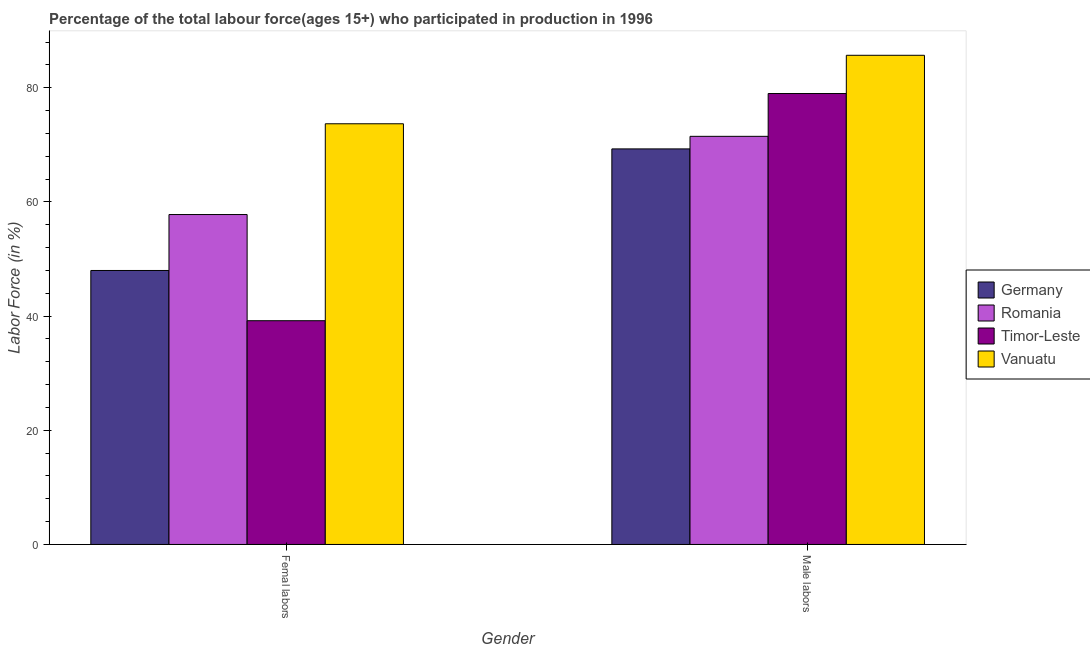How many different coloured bars are there?
Provide a short and direct response. 4. Are the number of bars on each tick of the X-axis equal?
Give a very brief answer. Yes. How many bars are there on the 2nd tick from the left?
Give a very brief answer. 4. What is the label of the 1st group of bars from the left?
Your answer should be very brief. Femal labors. What is the percentage of male labour force in Germany?
Offer a very short reply. 69.3. Across all countries, what is the maximum percentage of female labor force?
Provide a succinct answer. 73.7. Across all countries, what is the minimum percentage of male labour force?
Provide a succinct answer. 69.3. In which country was the percentage of male labour force maximum?
Provide a short and direct response. Vanuatu. In which country was the percentage of male labour force minimum?
Provide a succinct answer. Germany. What is the total percentage of male labour force in the graph?
Your answer should be very brief. 305.5. What is the difference between the percentage of female labor force in Timor-Leste and that in Romania?
Offer a terse response. -18.6. What is the difference between the percentage of male labour force in Germany and the percentage of female labor force in Timor-Leste?
Your answer should be compact. 30.1. What is the average percentage of female labor force per country?
Give a very brief answer. 54.67. What is the difference between the percentage of male labour force and percentage of female labor force in Germany?
Offer a terse response. 21.3. What is the ratio of the percentage of female labor force in Timor-Leste to that in Vanuatu?
Ensure brevity in your answer.  0.53. Is the percentage of male labour force in Vanuatu less than that in Timor-Leste?
Offer a very short reply. No. What does the 3rd bar from the left in Male labors represents?
Offer a terse response. Timor-Leste. What does the 4th bar from the right in Male labors represents?
Keep it short and to the point. Germany. Are the values on the major ticks of Y-axis written in scientific E-notation?
Your response must be concise. No. Does the graph contain grids?
Provide a succinct answer. No. How many legend labels are there?
Your answer should be compact. 4. How are the legend labels stacked?
Your answer should be compact. Vertical. What is the title of the graph?
Give a very brief answer. Percentage of the total labour force(ages 15+) who participated in production in 1996. Does "Trinidad and Tobago" appear as one of the legend labels in the graph?
Your response must be concise. No. What is the Labor Force (in %) in Romania in Femal labors?
Your answer should be compact. 57.8. What is the Labor Force (in %) of Timor-Leste in Femal labors?
Make the answer very short. 39.2. What is the Labor Force (in %) of Vanuatu in Femal labors?
Give a very brief answer. 73.7. What is the Labor Force (in %) in Germany in Male labors?
Your answer should be very brief. 69.3. What is the Labor Force (in %) in Romania in Male labors?
Ensure brevity in your answer.  71.5. What is the Labor Force (in %) of Timor-Leste in Male labors?
Offer a very short reply. 79. What is the Labor Force (in %) in Vanuatu in Male labors?
Give a very brief answer. 85.7. Across all Gender, what is the maximum Labor Force (in %) of Germany?
Keep it short and to the point. 69.3. Across all Gender, what is the maximum Labor Force (in %) of Romania?
Offer a terse response. 71.5. Across all Gender, what is the maximum Labor Force (in %) of Timor-Leste?
Ensure brevity in your answer.  79. Across all Gender, what is the maximum Labor Force (in %) in Vanuatu?
Your answer should be compact. 85.7. Across all Gender, what is the minimum Labor Force (in %) of Germany?
Make the answer very short. 48. Across all Gender, what is the minimum Labor Force (in %) in Romania?
Make the answer very short. 57.8. Across all Gender, what is the minimum Labor Force (in %) in Timor-Leste?
Your answer should be very brief. 39.2. Across all Gender, what is the minimum Labor Force (in %) in Vanuatu?
Ensure brevity in your answer.  73.7. What is the total Labor Force (in %) in Germany in the graph?
Your answer should be very brief. 117.3. What is the total Labor Force (in %) of Romania in the graph?
Make the answer very short. 129.3. What is the total Labor Force (in %) in Timor-Leste in the graph?
Provide a short and direct response. 118.2. What is the total Labor Force (in %) in Vanuatu in the graph?
Ensure brevity in your answer.  159.4. What is the difference between the Labor Force (in %) of Germany in Femal labors and that in Male labors?
Ensure brevity in your answer.  -21.3. What is the difference between the Labor Force (in %) in Romania in Femal labors and that in Male labors?
Keep it short and to the point. -13.7. What is the difference between the Labor Force (in %) in Timor-Leste in Femal labors and that in Male labors?
Ensure brevity in your answer.  -39.8. What is the difference between the Labor Force (in %) in Vanuatu in Femal labors and that in Male labors?
Your answer should be very brief. -12. What is the difference between the Labor Force (in %) of Germany in Femal labors and the Labor Force (in %) of Romania in Male labors?
Keep it short and to the point. -23.5. What is the difference between the Labor Force (in %) of Germany in Femal labors and the Labor Force (in %) of Timor-Leste in Male labors?
Provide a succinct answer. -31. What is the difference between the Labor Force (in %) of Germany in Femal labors and the Labor Force (in %) of Vanuatu in Male labors?
Give a very brief answer. -37.7. What is the difference between the Labor Force (in %) in Romania in Femal labors and the Labor Force (in %) in Timor-Leste in Male labors?
Ensure brevity in your answer.  -21.2. What is the difference between the Labor Force (in %) in Romania in Femal labors and the Labor Force (in %) in Vanuatu in Male labors?
Make the answer very short. -27.9. What is the difference between the Labor Force (in %) of Timor-Leste in Femal labors and the Labor Force (in %) of Vanuatu in Male labors?
Your answer should be very brief. -46.5. What is the average Labor Force (in %) in Germany per Gender?
Your response must be concise. 58.65. What is the average Labor Force (in %) of Romania per Gender?
Keep it short and to the point. 64.65. What is the average Labor Force (in %) of Timor-Leste per Gender?
Your answer should be compact. 59.1. What is the average Labor Force (in %) in Vanuatu per Gender?
Ensure brevity in your answer.  79.7. What is the difference between the Labor Force (in %) of Germany and Labor Force (in %) of Romania in Femal labors?
Your response must be concise. -9.8. What is the difference between the Labor Force (in %) in Germany and Labor Force (in %) in Timor-Leste in Femal labors?
Ensure brevity in your answer.  8.8. What is the difference between the Labor Force (in %) in Germany and Labor Force (in %) in Vanuatu in Femal labors?
Offer a very short reply. -25.7. What is the difference between the Labor Force (in %) of Romania and Labor Force (in %) of Timor-Leste in Femal labors?
Provide a short and direct response. 18.6. What is the difference between the Labor Force (in %) in Romania and Labor Force (in %) in Vanuatu in Femal labors?
Make the answer very short. -15.9. What is the difference between the Labor Force (in %) of Timor-Leste and Labor Force (in %) of Vanuatu in Femal labors?
Your answer should be very brief. -34.5. What is the difference between the Labor Force (in %) of Germany and Labor Force (in %) of Romania in Male labors?
Your answer should be compact. -2.2. What is the difference between the Labor Force (in %) in Germany and Labor Force (in %) in Timor-Leste in Male labors?
Provide a short and direct response. -9.7. What is the difference between the Labor Force (in %) of Germany and Labor Force (in %) of Vanuatu in Male labors?
Keep it short and to the point. -16.4. What is the difference between the Labor Force (in %) in Romania and Labor Force (in %) in Timor-Leste in Male labors?
Give a very brief answer. -7.5. What is the difference between the Labor Force (in %) of Timor-Leste and Labor Force (in %) of Vanuatu in Male labors?
Make the answer very short. -6.7. What is the ratio of the Labor Force (in %) of Germany in Femal labors to that in Male labors?
Offer a very short reply. 0.69. What is the ratio of the Labor Force (in %) in Romania in Femal labors to that in Male labors?
Provide a succinct answer. 0.81. What is the ratio of the Labor Force (in %) of Timor-Leste in Femal labors to that in Male labors?
Give a very brief answer. 0.5. What is the ratio of the Labor Force (in %) of Vanuatu in Femal labors to that in Male labors?
Provide a succinct answer. 0.86. What is the difference between the highest and the second highest Labor Force (in %) in Germany?
Offer a very short reply. 21.3. What is the difference between the highest and the second highest Labor Force (in %) in Romania?
Your answer should be compact. 13.7. What is the difference between the highest and the second highest Labor Force (in %) in Timor-Leste?
Keep it short and to the point. 39.8. What is the difference between the highest and the second highest Labor Force (in %) of Vanuatu?
Your answer should be compact. 12. What is the difference between the highest and the lowest Labor Force (in %) of Germany?
Your answer should be compact. 21.3. What is the difference between the highest and the lowest Labor Force (in %) of Romania?
Provide a short and direct response. 13.7. What is the difference between the highest and the lowest Labor Force (in %) in Timor-Leste?
Your response must be concise. 39.8. What is the difference between the highest and the lowest Labor Force (in %) of Vanuatu?
Offer a terse response. 12. 